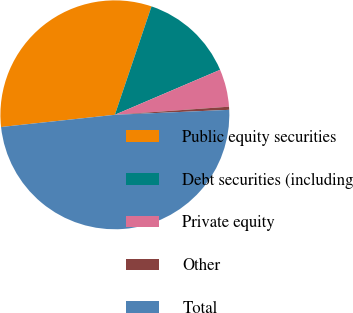<chart> <loc_0><loc_0><loc_500><loc_500><pie_chart><fcel>Public equity securities<fcel>Debt securities (including<fcel>Private equity<fcel>Other<fcel>Total<nl><fcel>31.89%<fcel>13.38%<fcel>5.3%<fcel>0.44%<fcel>48.99%<nl></chart> 